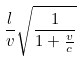<formula> <loc_0><loc_0><loc_500><loc_500>\frac { l } { v } \sqrt { \frac { 1 } { 1 + \frac { v } { c } } }</formula> 